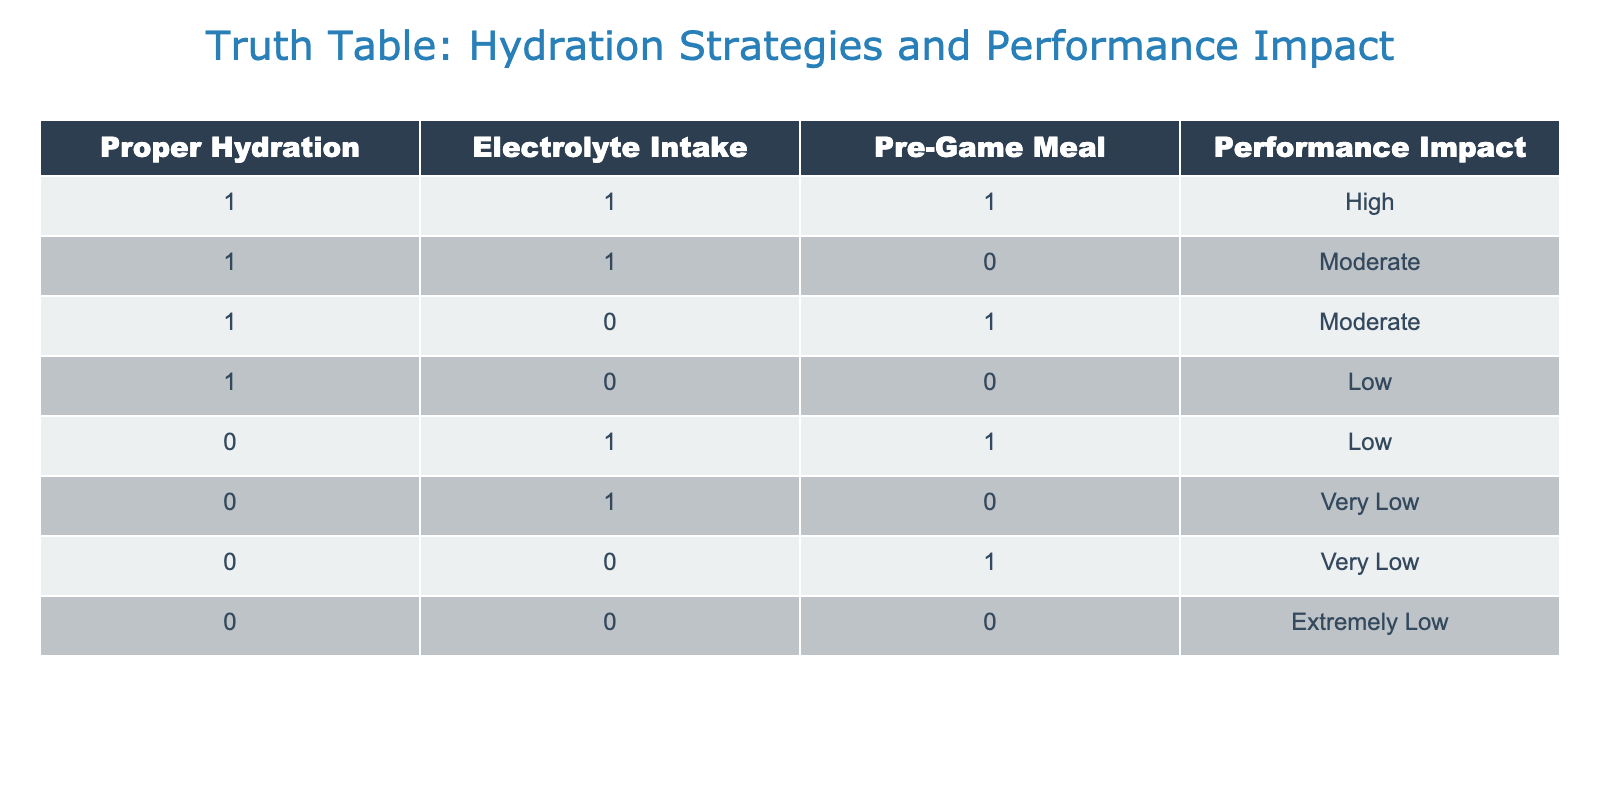What is the performance impact when proper hydration, electrolyte intake, and a pre-game meal are all present? According to the table, when all three conditions are met (1, 1, 1), the performance impact is categorized as "High."
Answer: High What is the performance impact when proper hydration is low? The table shows that when proper hydration is low (0), the performance impacts listed are "Low," "Very Low," and "Extremely Low." Therefore, there are three potential performance impacts based on different combinations of the other two variables.
Answer: Low, Very Low, Extremely Low How many rows in the table indicate a "Moderate" performance impact? By inspecting the table, there are two rows with a "Moderate" performance impact: one where both proper hydration and electrolyte intake are present but no pre-game meal (1, 1, 0) and one where proper hydration is present and a pre-game meal is given but no electrolyte intake (1, 0, 1). Therefore, the count is 2.
Answer: 2 Is having electrolyte intake and no pre-game meal enough for a moderate performance impact? Yes, when we check the row with electrolyte intake (1) and no pre-game meal (0) while having proper hydration (1), the performance impact is "Moderate." Hence, it confirms the condition meets the required impact level.
Answer: Yes What is the average performance impact level for cases with both proper hydration and electrolyte intake? In the table, there are three relevant cases: (1, 1, 1) with "High," (1, 1, 0) with "Moderate," and aggregating the qualitative values into a numerical scale (High=3, Moderate=2), averaging (3 + 2) / 2 = 2.5 which corresponds to "Moderate."
Answer: Moderate If a player neglects both proper hydration and electrolyte intake but consumes a pre-game meal, what will the performance impact be? The table indicates that neglecting both proper hydration (0) and electrolyte intake (0) while having a pre-game meal (1) results in a performance impact of "Very Low."
Answer: Very Low How does performance impact relate to the presence of electrolyte intake when proper hydration is absent? When proper hydration is absent (0), the electrolyte intake alters the impact: a combination of electrolyte intake and pre-game meal (0, 1, 1) is "Low" and without the pre-game meal (0, 1, 0) is "Very Low." Therefore, the presence of electrolyte intake seems to enhance performance slightly but is overall low without hydration.
Answer: It enhances performance slightly What is the performance impact if a player is properly hydrated and has a pre-game meal but does not have electrolyte intake? The specific row in the table shows that when the player is properly hydrated (1), has a pre-game meal (1), but is without electrolyte intake (0), the performance impact is classified as "Moderate."
Answer: Moderate 